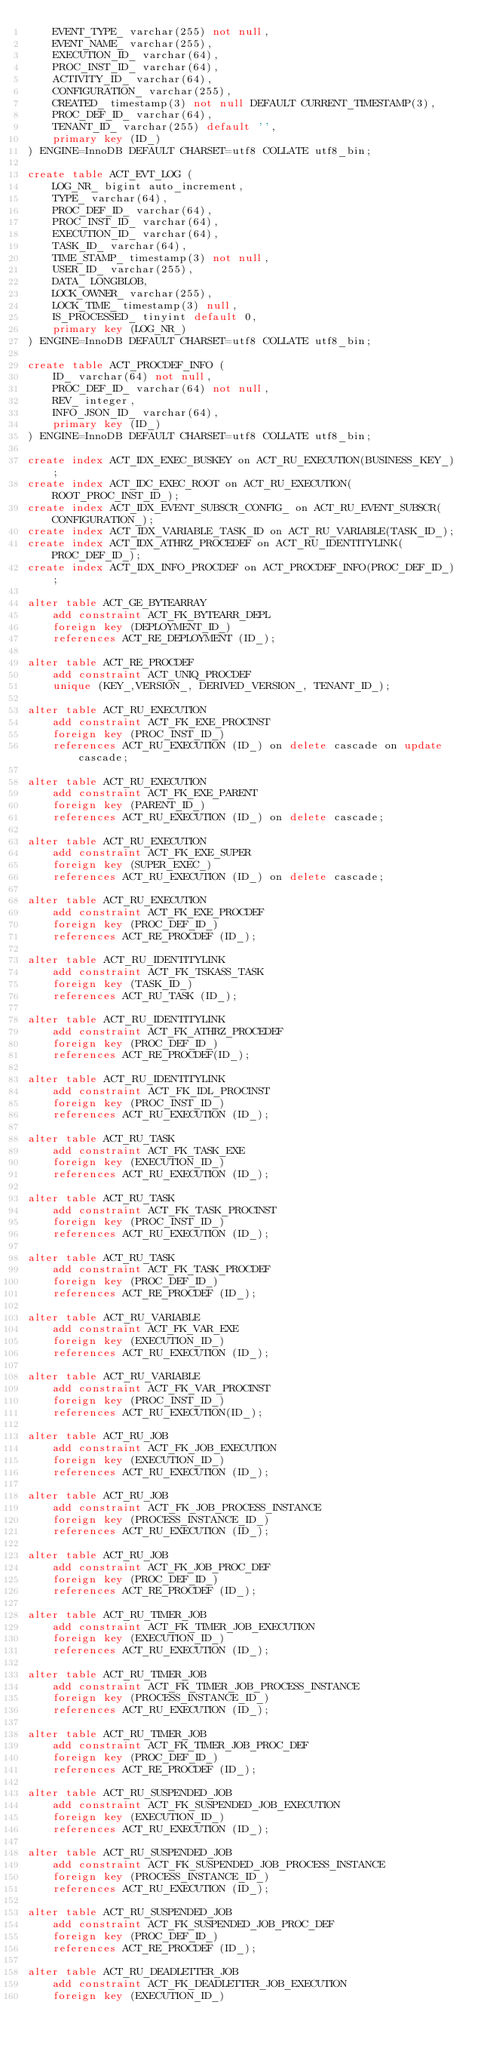<code> <loc_0><loc_0><loc_500><loc_500><_SQL_>    EVENT_TYPE_ varchar(255) not null,
    EVENT_NAME_ varchar(255),
    EXECUTION_ID_ varchar(64),
    PROC_INST_ID_ varchar(64),
    ACTIVITY_ID_ varchar(64),
    CONFIGURATION_ varchar(255),
    CREATED_ timestamp(3) not null DEFAULT CURRENT_TIMESTAMP(3),
    PROC_DEF_ID_ varchar(64),
    TENANT_ID_ varchar(255) default '',
    primary key (ID_)
) ENGINE=InnoDB DEFAULT CHARSET=utf8 COLLATE utf8_bin;

create table ACT_EVT_LOG (
    LOG_NR_ bigint auto_increment,
    TYPE_ varchar(64),
    PROC_DEF_ID_ varchar(64),
    PROC_INST_ID_ varchar(64),
    EXECUTION_ID_ varchar(64),
    TASK_ID_ varchar(64),
    TIME_STAMP_ timestamp(3) not null,
    USER_ID_ varchar(255),
    DATA_ LONGBLOB,
    LOCK_OWNER_ varchar(255),
    LOCK_TIME_ timestamp(3) null,
    IS_PROCESSED_ tinyint default 0,
    primary key (LOG_NR_)
) ENGINE=InnoDB DEFAULT CHARSET=utf8 COLLATE utf8_bin;

create table ACT_PROCDEF_INFO (
	ID_ varchar(64) not null,
    PROC_DEF_ID_ varchar(64) not null,
    REV_ integer,
    INFO_JSON_ID_ varchar(64),
    primary key (ID_)
) ENGINE=InnoDB DEFAULT CHARSET=utf8 COLLATE utf8_bin;

create index ACT_IDX_EXEC_BUSKEY on ACT_RU_EXECUTION(BUSINESS_KEY_);
create index ACT_IDC_EXEC_ROOT on ACT_RU_EXECUTION(ROOT_PROC_INST_ID_);
create index ACT_IDX_EVENT_SUBSCR_CONFIG_ on ACT_RU_EVENT_SUBSCR(CONFIGURATION_);
create index ACT_IDX_VARIABLE_TASK_ID on ACT_RU_VARIABLE(TASK_ID_);
create index ACT_IDX_ATHRZ_PROCEDEF on ACT_RU_IDENTITYLINK(PROC_DEF_ID_);
create index ACT_IDX_INFO_PROCDEF on ACT_PROCDEF_INFO(PROC_DEF_ID_);

alter table ACT_GE_BYTEARRAY
    add constraint ACT_FK_BYTEARR_DEPL 
    foreign key (DEPLOYMENT_ID_) 
    references ACT_RE_DEPLOYMENT (ID_);

alter table ACT_RE_PROCDEF
    add constraint ACT_UNIQ_PROCDEF
    unique (KEY_,VERSION_, DERIVED_VERSION_, TENANT_ID_);
    
alter table ACT_RU_EXECUTION
    add constraint ACT_FK_EXE_PROCINST 
    foreign key (PROC_INST_ID_) 
    references ACT_RU_EXECUTION (ID_) on delete cascade on update cascade;

alter table ACT_RU_EXECUTION
    add constraint ACT_FK_EXE_PARENT 
    foreign key (PARENT_ID_) 
    references ACT_RU_EXECUTION (ID_) on delete cascade;
    
alter table ACT_RU_EXECUTION
    add constraint ACT_FK_EXE_SUPER 
    foreign key (SUPER_EXEC_) 
    references ACT_RU_EXECUTION (ID_) on delete cascade;
    
alter table ACT_RU_EXECUTION
    add constraint ACT_FK_EXE_PROCDEF 
    foreign key (PROC_DEF_ID_) 
    references ACT_RE_PROCDEF (ID_);
    
alter table ACT_RU_IDENTITYLINK
    add constraint ACT_FK_TSKASS_TASK 
    foreign key (TASK_ID_) 
    references ACT_RU_TASK (ID_);
    
alter table ACT_RU_IDENTITYLINK
    add constraint ACT_FK_ATHRZ_PROCEDEF 
    foreign key (PROC_DEF_ID_) 
    references ACT_RE_PROCDEF(ID_);
    
alter table ACT_RU_IDENTITYLINK
    add constraint ACT_FK_IDL_PROCINST
    foreign key (PROC_INST_ID_) 
    references ACT_RU_EXECUTION (ID_);       
    
alter table ACT_RU_TASK
    add constraint ACT_FK_TASK_EXE
    foreign key (EXECUTION_ID_)
    references ACT_RU_EXECUTION (ID_);
    
alter table ACT_RU_TASK
    add constraint ACT_FK_TASK_PROCINST
    foreign key (PROC_INST_ID_)
    references ACT_RU_EXECUTION (ID_);
    
alter table ACT_RU_TASK
  	add constraint ACT_FK_TASK_PROCDEF
  	foreign key (PROC_DEF_ID_)
  	references ACT_RE_PROCDEF (ID_);
  
alter table ACT_RU_VARIABLE 
    add constraint ACT_FK_VAR_EXE 
    foreign key (EXECUTION_ID_) 
    references ACT_RU_EXECUTION (ID_);

alter table ACT_RU_VARIABLE
    add constraint ACT_FK_VAR_PROCINST
    foreign key (PROC_INST_ID_)
    references ACT_RU_EXECUTION(ID_);

alter table ACT_RU_JOB 
    add constraint ACT_FK_JOB_EXECUTION 
    foreign key (EXECUTION_ID_) 
    references ACT_RU_EXECUTION (ID_);
    
alter table ACT_RU_JOB 
    add constraint ACT_FK_JOB_PROCESS_INSTANCE 
    foreign key (PROCESS_INSTANCE_ID_) 
    references ACT_RU_EXECUTION (ID_);
    
alter table ACT_RU_JOB 
    add constraint ACT_FK_JOB_PROC_DEF
    foreign key (PROC_DEF_ID_) 
    references ACT_RE_PROCDEF (ID_);

alter table ACT_RU_TIMER_JOB 
    add constraint ACT_FK_TIMER_JOB_EXECUTION 
    foreign key (EXECUTION_ID_) 
    references ACT_RU_EXECUTION (ID_);
    
alter table ACT_RU_TIMER_JOB 
    add constraint ACT_FK_TIMER_JOB_PROCESS_INSTANCE 
    foreign key (PROCESS_INSTANCE_ID_) 
    references ACT_RU_EXECUTION (ID_);
    
alter table ACT_RU_TIMER_JOB 
    add constraint ACT_FK_TIMER_JOB_PROC_DEF
    foreign key (PROC_DEF_ID_) 
    references ACT_RE_PROCDEF (ID_);
    
alter table ACT_RU_SUSPENDED_JOB 
    add constraint ACT_FK_SUSPENDED_JOB_EXECUTION 
    foreign key (EXECUTION_ID_) 
    references ACT_RU_EXECUTION (ID_);
    
alter table ACT_RU_SUSPENDED_JOB 
    add constraint ACT_FK_SUSPENDED_JOB_PROCESS_INSTANCE 
    foreign key (PROCESS_INSTANCE_ID_) 
    references ACT_RU_EXECUTION (ID_);
    
alter table ACT_RU_SUSPENDED_JOB 
    add constraint ACT_FK_SUSPENDED_JOB_PROC_DEF
    foreign key (PROC_DEF_ID_) 
    references ACT_RE_PROCDEF (ID_);
    
alter table ACT_RU_DEADLETTER_JOB 
    add constraint ACT_FK_DEADLETTER_JOB_EXECUTION 
    foreign key (EXECUTION_ID_) </code> 